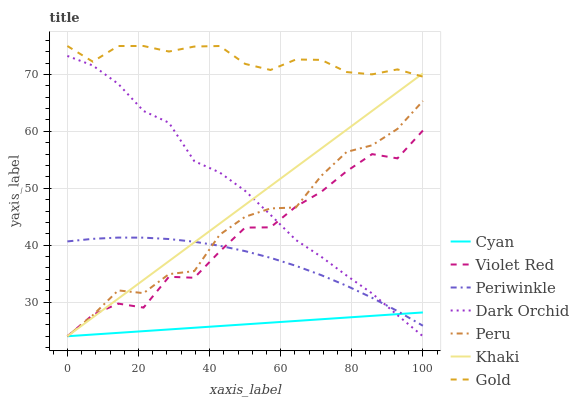Does Khaki have the minimum area under the curve?
Answer yes or no. No. Does Khaki have the maximum area under the curve?
Answer yes or no. No. Is Khaki the smoothest?
Answer yes or no. No. Is Khaki the roughest?
Answer yes or no. No. Does Gold have the lowest value?
Answer yes or no. No. Does Khaki have the highest value?
Answer yes or no. No. Is Periwinkle less than Gold?
Answer yes or no. Yes. Is Gold greater than Cyan?
Answer yes or no. Yes. Does Periwinkle intersect Gold?
Answer yes or no. No. 